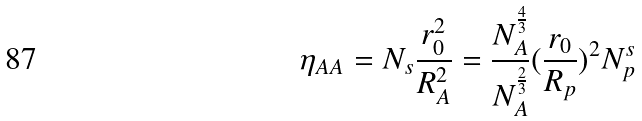Convert formula to latex. <formula><loc_0><loc_0><loc_500><loc_500>\eta _ { A A } = N _ { s } \frac { r _ { 0 } ^ { 2 } } { R _ { A } ^ { 2 } } = \frac { N _ { A } ^ { \frac { 4 } { 3 } } } { N _ { A } ^ { \frac { 2 } { 3 } } } ( \frac { r _ { 0 } } { R _ { p } } ) ^ { 2 } N _ { p } ^ { s }</formula> 